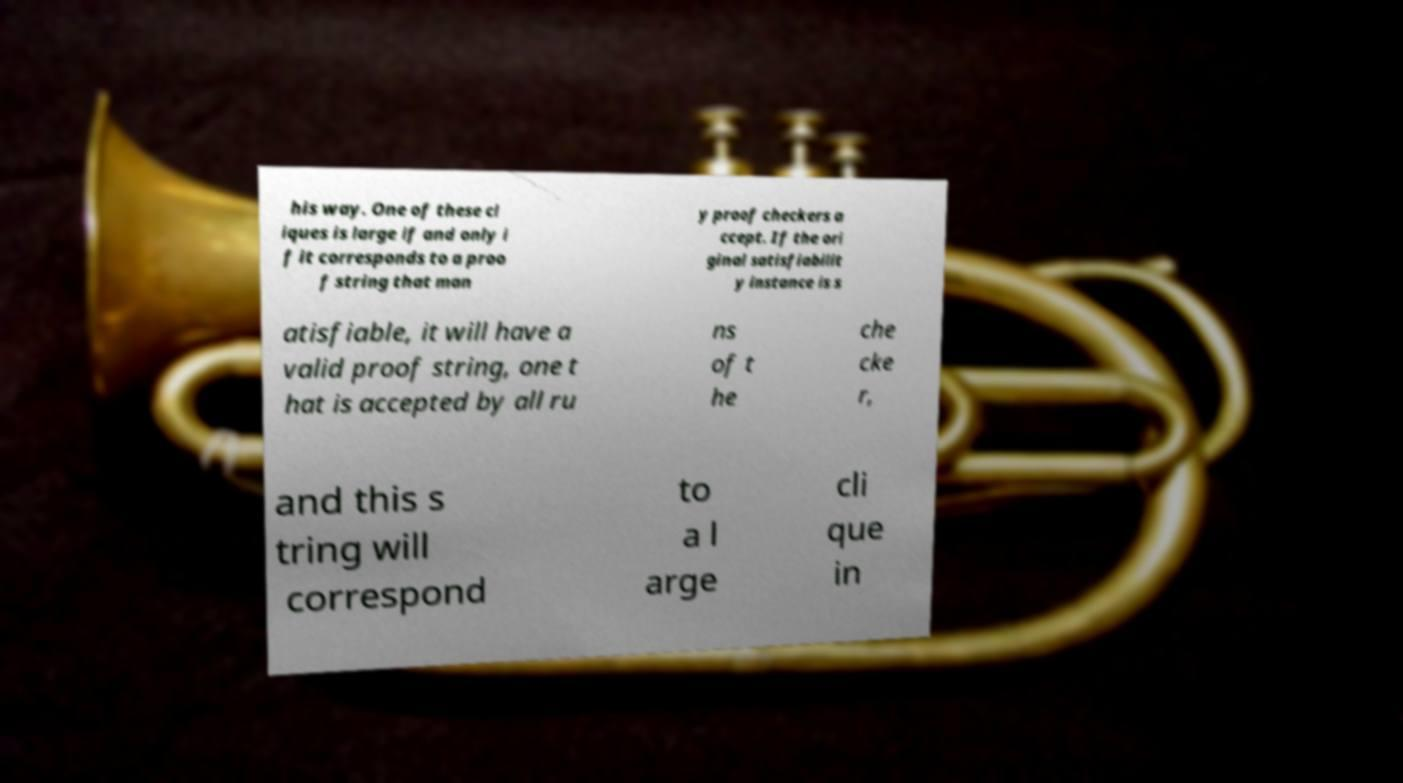Please read and relay the text visible in this image. What does it say? his way. One of these cl iques is large if and only i f it corresponds to a proo f string that man y proof checkers a ccept. If the ori ginal satisfiabilit y instance is s atisfiable, it will have a valid proof string, one t hat is accepted by all ru ns of t he che cke r, and this s tring will correspond to a l arge cli que in 